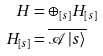<formula> <loc_0><loc_0><loc_500><loc_500>H & = \oplus _ { \left [ s \right ] } H _ { \left [ s \right ] } \\ H _ { \left [ s \right ] } & = \overline { \mathcal { A } \left | s \right \rangle }</formula> 